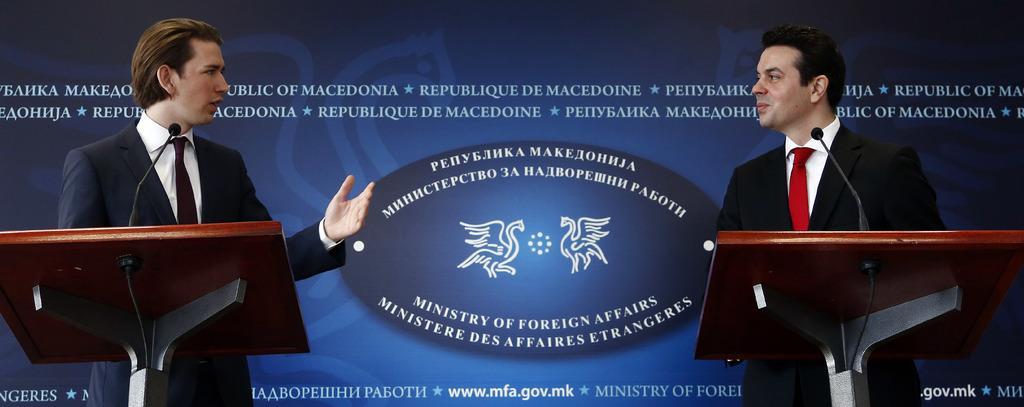In one or two sentences, can you explain what this image depicts? In the picture I can see two men are standing in front of podiums which has microphones on them. These men are wearing suits, ties and shirts. In the background I can see something written on a banner. 